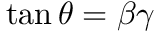<formula> <loc_0><loc_0><loc_500><loc_500>\tan \theta = \beta \gamma</formula> 